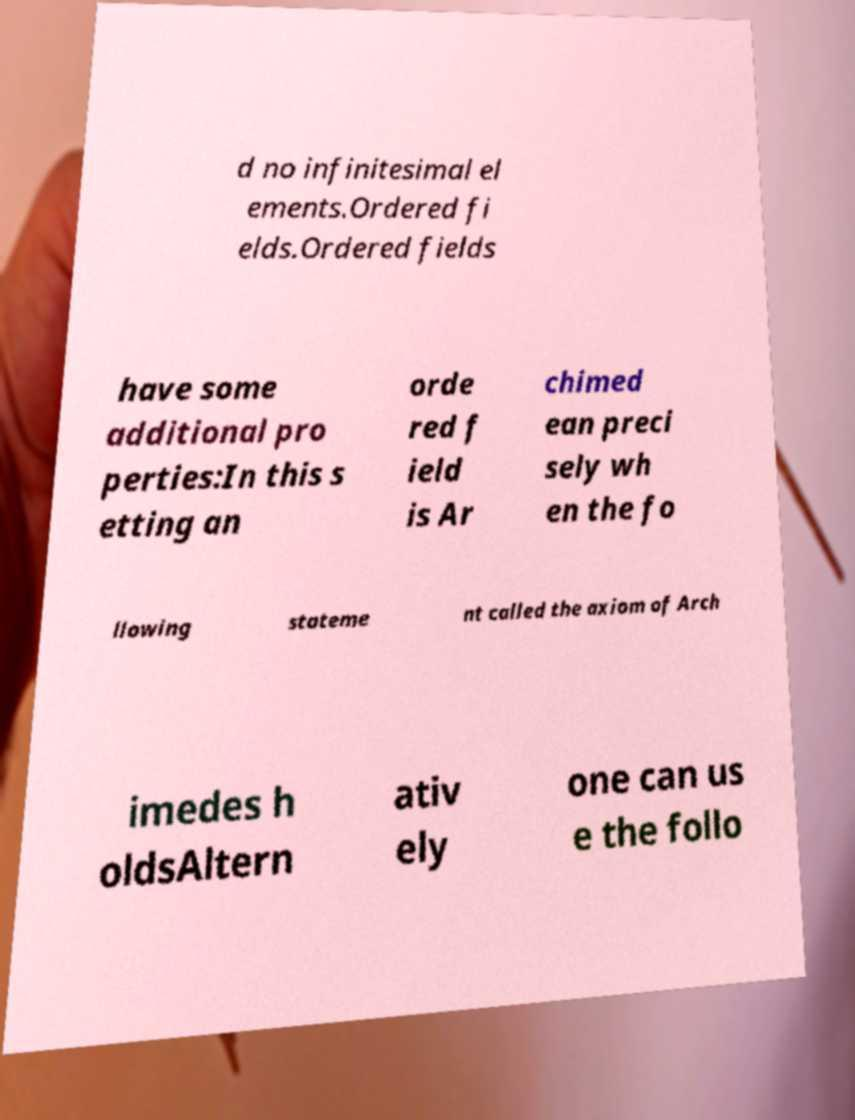Please identify and transcribe the text found in this image. d no infinitesimal el ements.Ordered fi elds.Ordered fields have some additional pro perties:In this s etting an orde red f ield is Ar chimed ean preci sely wh en the fo llowing stateme nt called the axiom of Arch imedes h oldsAltern ativ ely one can us e the follo 